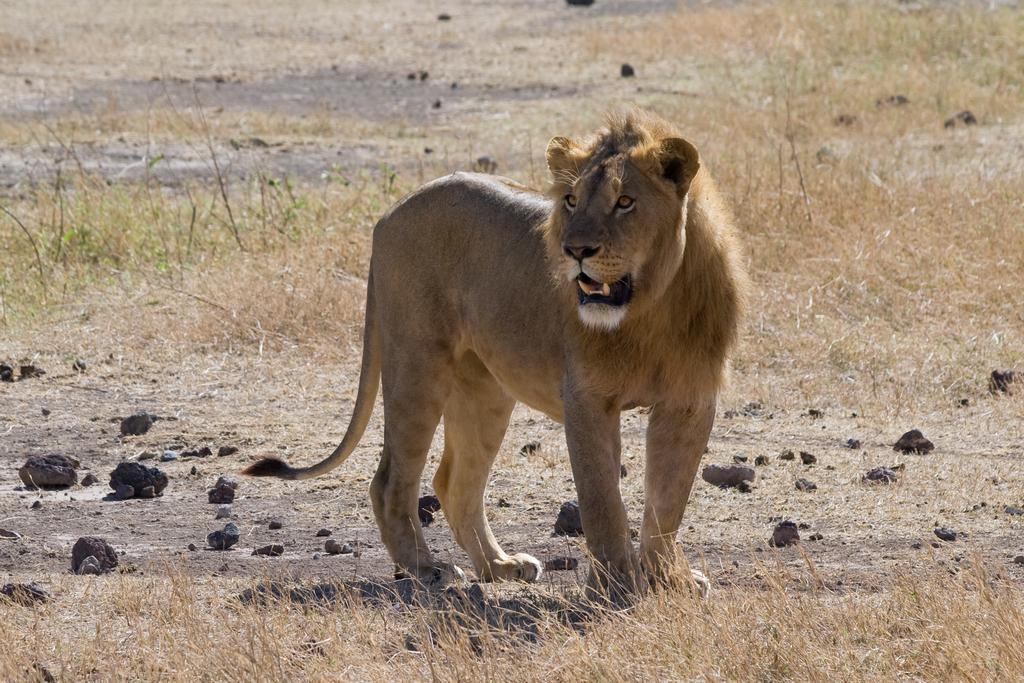What animal is in the image? There is a lion in the image. Where is the lion located in the image? The lion is standing on a path. What type of surface can be seen on the path? There are stones visible in the image. What type of vegetation is present on the ground? Grass is present on the ground. What type of pet is the lion paying attention to in the image? There is no pet present in the image, and the lion is not paying attention to any pet. 